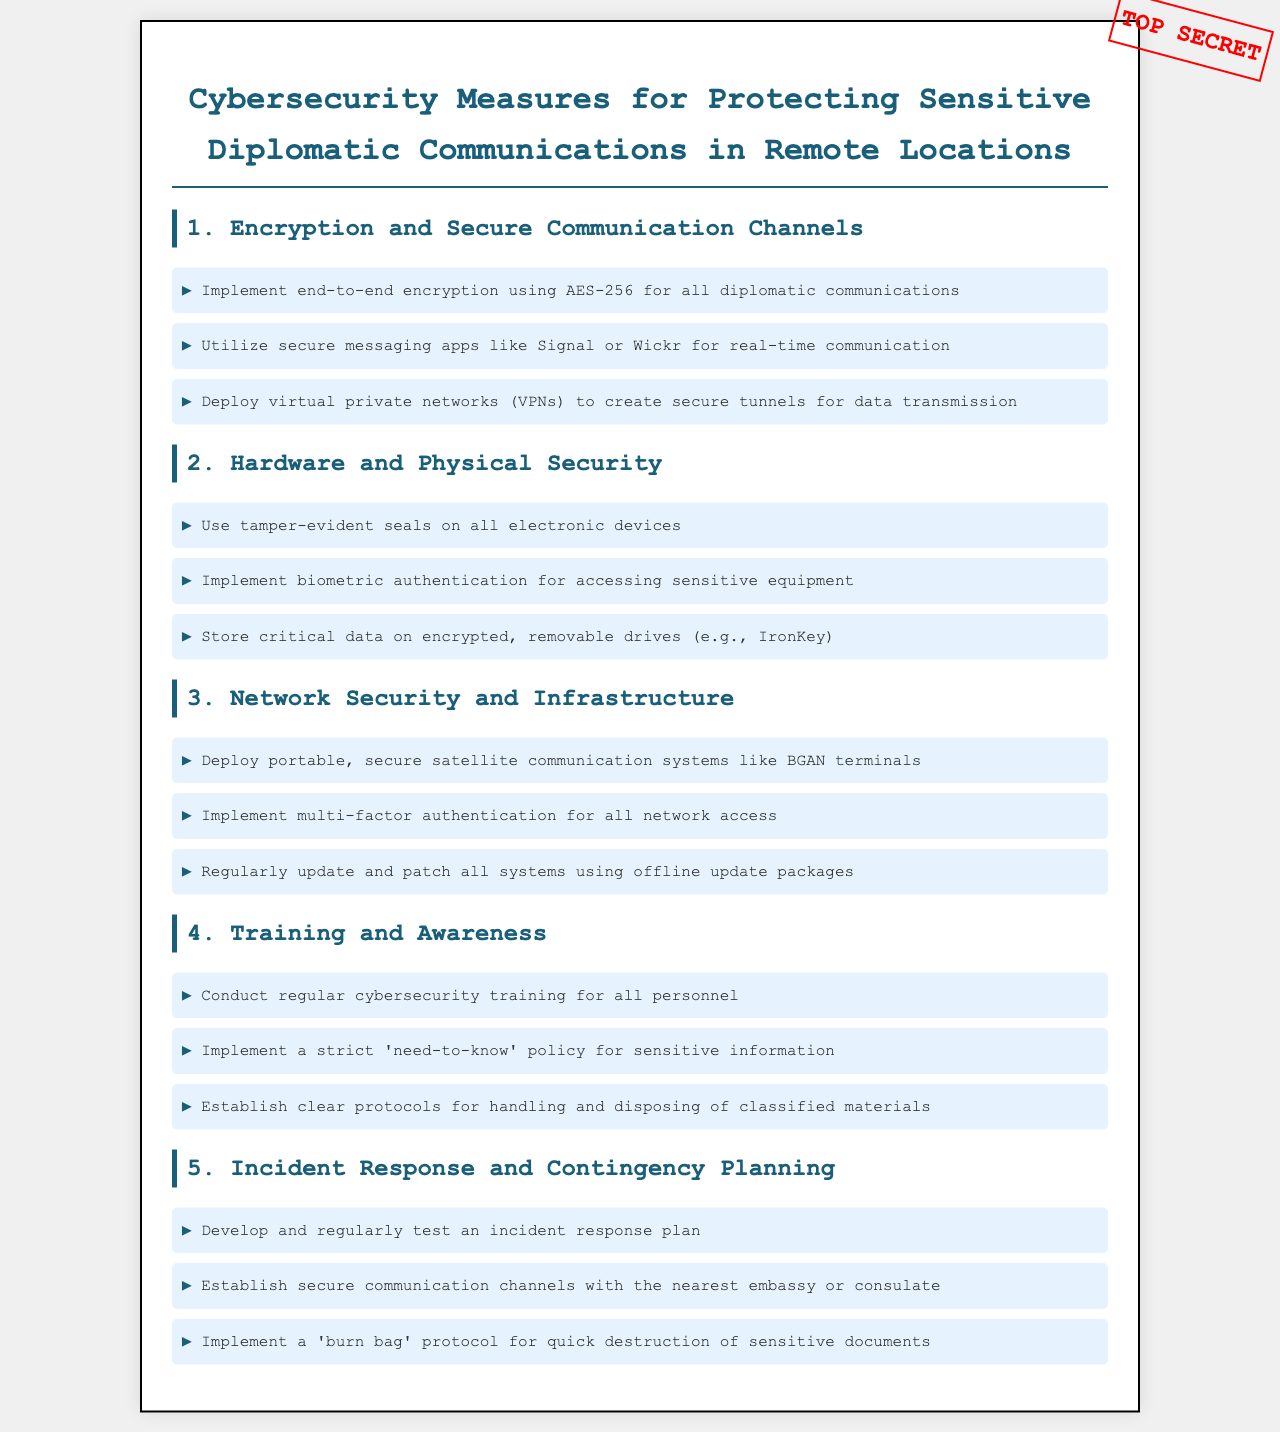What encryption standard should be used for communications? The document specifies the use of AES-256 as the encryption standard for diplomatic communications.
Answer: AES-256 Which messaging apps are recommended for real-time communication? The document recommends secure messaging apps like Signal or Wickr for real-time communication.
Answer: Signal, Wickr What type of devices should have tamper-evident seals? The document states that all electronic devices should have tamper-evident seals.
Answer: Electronic devices How often should cybersecurity training be conducted? The document mentions conducting regular cybersecurity training for all personnel without specifying a frequency.
Answer: Regularly What is the purpose of a burn bag? The burn bag protocol is implemented for the quick destruction of sensitive documents.
Answer: Quick destruction of sensitive documents What type of authentication should be used for network access? The document recommends multi-factor authentication for all network access.
Answer: Multi-factor authentication Which communication systems are mentioned for secure satellite communication? The document mentions deploying portable, secure satellite communication systems like BGAN terminals.
Answer: BGAN terminals What protocol should be established with embassies or consulates? The document specifies the establishment of secure communication channels with the nearest embassy or consulate.
Answer: Secure communication channels 